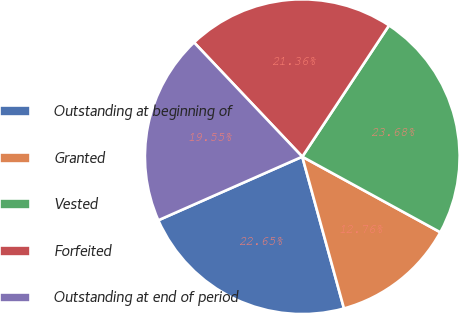Convert chart. <chart><loc_0><loc_0><loc_500><loc_500><pie_chart><fcel>Outstanding at beginning of<fcel>Granted<fcel>Vested<fcel>Forfeited<fcel>Outstanding at end of period<nl><fcel>22.65%<fcel>12.76%<fcel>23.68%<fcel>21.36%<fcel>19.55%<nl></chart> 